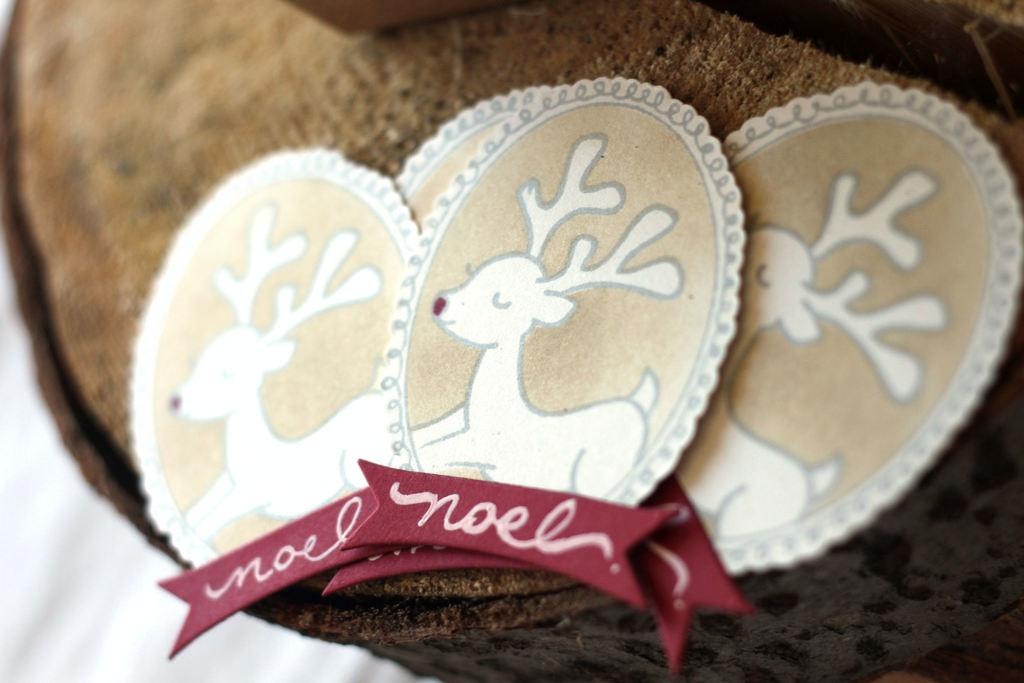What type of objects are on the wooden piece in the image? There are small cards with animal pictures on them. Can you describe the wooden piece in the image? The cards are on a wooden piece. Is there any part of the image that is blurred or unclear? Yes, the image is blurred on the left side at the bottom. What type of kettle is visible on the wooden piece in the image? There is no kettle present in the image; it features small cards with animal pictures on a wooden piece. What kind of apparatus is used to spin the wheel in the image? There is no wheel or apparatus present in the image. 